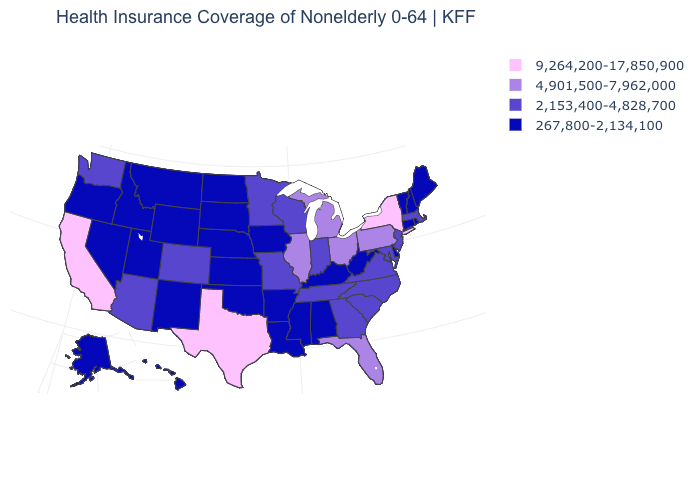Name the states that have a value in the range 267,800-2,134,100?
Short answer required. Alabama, Alaska, Arkansas, Connecticut, Delaware, Hawaii, Idaho, Iowa, Kansas, Kentucky, Louisiana, Maine, Mississippi, Montana, Nebraska, Nevada, New Hampshire, New Mexico, North Dakota, Oklahoma, Oregon, Rhode Island, South Dakota, Utah, Vermont, West Virginia, Wyoming. What is the value of New Mexico?
Answer briefly. 267,800-2,134,100. What is the value of Iowa?
Keep it brief. 267,800-2,134,100. What is the value of Hawaii?
Quick response, please. 267,800-2,134,100. Name the states that have a value in the range 4,901,500-7,962,000?
Answer briefly. Florida, Illinois, Michigan, Ohio, Pennsylvania. What is the value of Connecticut?
Quick response, please. 267,800-2,134,100. What is the highest value in states that border Iowa?
Keep it brief. 4,901,500-7,962,000. What is the value of Delaware?
Answer briefly. 267,800-2,134,100. How many symbols are there in the legend?
Quick response, please. 4. Which states hav the highest value in the South?
Quick response, please. Texas. Name the states that have a value in the range 9,264,200-17,850,900?
Keep it brief. California, New York, Texas. Which states have the highest value in the USA?
Short answer required. California, New York, Texas. Among the states that border Kansas , does Colorado have the highest value?
Answer briefly. Yes. What is the highest value in the MidWest ?
Short answer required. 4,901,500-7,962,000. What is the highest value in the USA?
Write a very short answer. 9,264,200-17,850,900. 